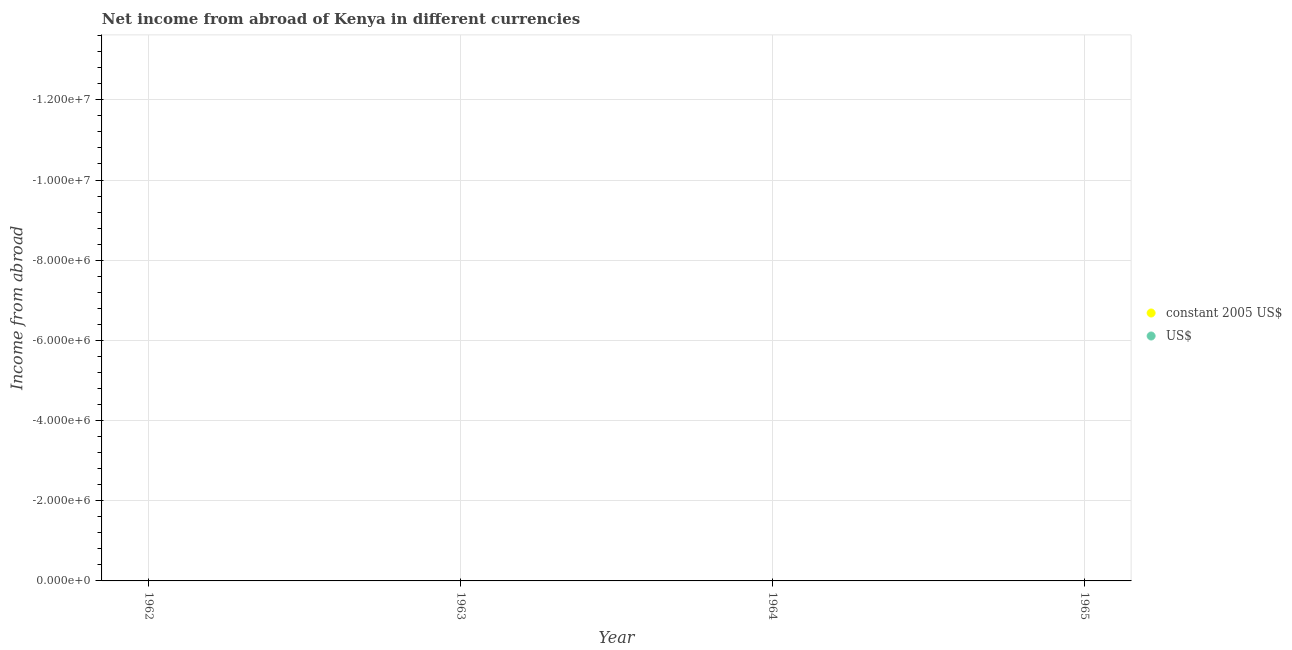How many different coloured dotlines are there?
Ensure brevity in your answer.  0. What is the income from abroad in us$ in 1965?
Offer a very short reply. 0. Across all years, what is the minimum income from abroad in us$?
Provide a succinct answer. 0. In how many years, is the income from abroad in us$ greater than -4800000 units?
Your response must be concise. 0. Does the income from abroad in constant 2005 us$ monotonically increase over the years?
Make the answer very short. No. Is the income from abroad in constant 2005 us$ strictly greater than the income from abroad in us$ over the years?
Offer a terse response. No. Is the income from abroad in us$ strictly less than the income from abroad in constant 2005 us$ over the years?
Your answer should be very brief. No. What is the difference between two consecutive major ticks on the Y-axis?
Offer a terse response. 2.00e+06. Does the graph contain any zero values?
Provide a short and direct response. Yes. How many legend labels are there?
Your response must be concise. 2. How are the legend labels stacked?
Ensure brevity in your answer.  Vertical. What is the title of the graph?
Offer a terse response. Net income from abroad of Kenya in different currencies. What is the label or title of the Y-axis?
Provide a short and direct response. Income from abroad. What is the Income from abroad in US$ in 1962?
Make the answer very short. 0. What is the Income from abroad in constant 2005 US$ in 1965?
Offer a terse response. 0. What is the Income from abroad in US$ in 1965?
Make the answer very short. 0. What is the total Income from abroad of constant 2005 US$ in the graph?
Keep it short and to the point. 0. What is the average Income from abroad of constant 2005 US$ per year?
Offer a very short reply. 0. What is the average Income from abroad in US$ per year?
Your answer should be compact. 0. 